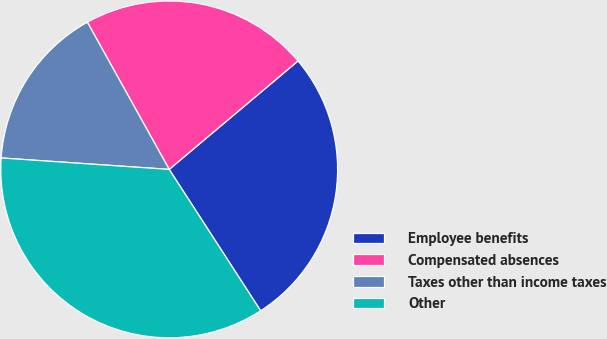<chart> <loc_0><loc_0><loc_500><loc_500><pie_chart><fcel>Employee benefits<fcel>Compensated absences<fcel>Taxes other than income taxes<fcel>Other<nl><fcel>27.0%<fcel>21.94%<fcel>15.84%<fcel>35.22%<nl></chart> 